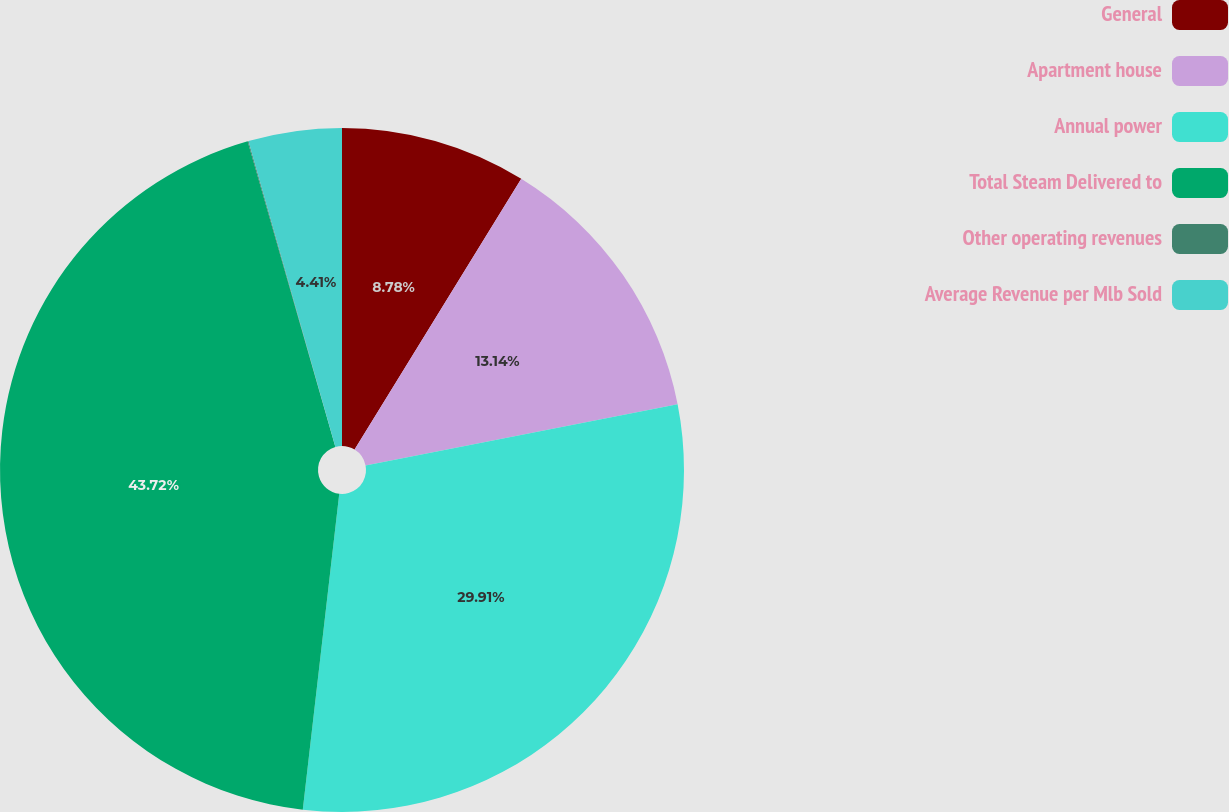Convert chart to OTSL. <chart><loc_0><loc_0><loc_500><loc_500><pie_chart><fcel>General<fcel>Apartment house<fcel>Annual power<fcel>Total Steam Delivered to<fcel>Other operating revenues<fcel>Average Revenue per Mlb Sold<nl><fcel>8.78%<fcel>13.14%<fcel>29.91%<fcel>43.72%<fcel>0.04%<fcel>4.41%<nl></chart> 